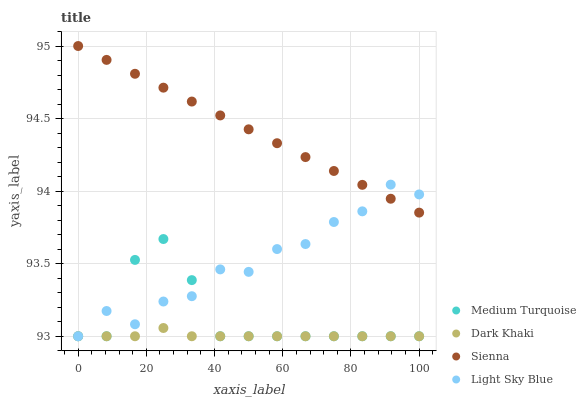Does Dark Khaki have the minimum area under the curve?
Answer yes or no. Yes. Does Sienna have the maximum area under the curve?
Answer yes or no. Yes. Does Light Sky Blue have the minimum area under the curve?
Answer yes or no. No. Does Light Sky Blue have the maximum area under the curve?
Answer yes or no. No. Is Sienna the smoothest?
Answer yes or no. Yes. Is Light Sky Blue the roughest?
Answer yes or no. Yes. Is Light Sky Blue the smoothest?
Answer yes or no. No. Is Sienna the roughest?
Answer yes or no. No. Does Dark Khaki have the lowest value?
Answer yes or no. Yes. Does Sienna have the lowest value?
Answer yes or no. No. Does Sienna have the highest value?
Answer yes or no. Yes. Does Light Sky Blue have the highest value?
Answer yes or no. No. Is Medium Turquoise less than Sienna?
Answer yes or no. Yes. Is Sienna greater than Medium Turquoise?
Answer yes or no. Yes. Does Light Sky Blue intersect Sienna?
Answer yes or no. Yes. Is Light Sky Blue less than Sienna?
Answer yes or no. No. Is Light Sky Blue greater than Sienna?
Answer yes or no. No. Does Medium Turquoise intersect Sienna?
Answer yes or no. No. 